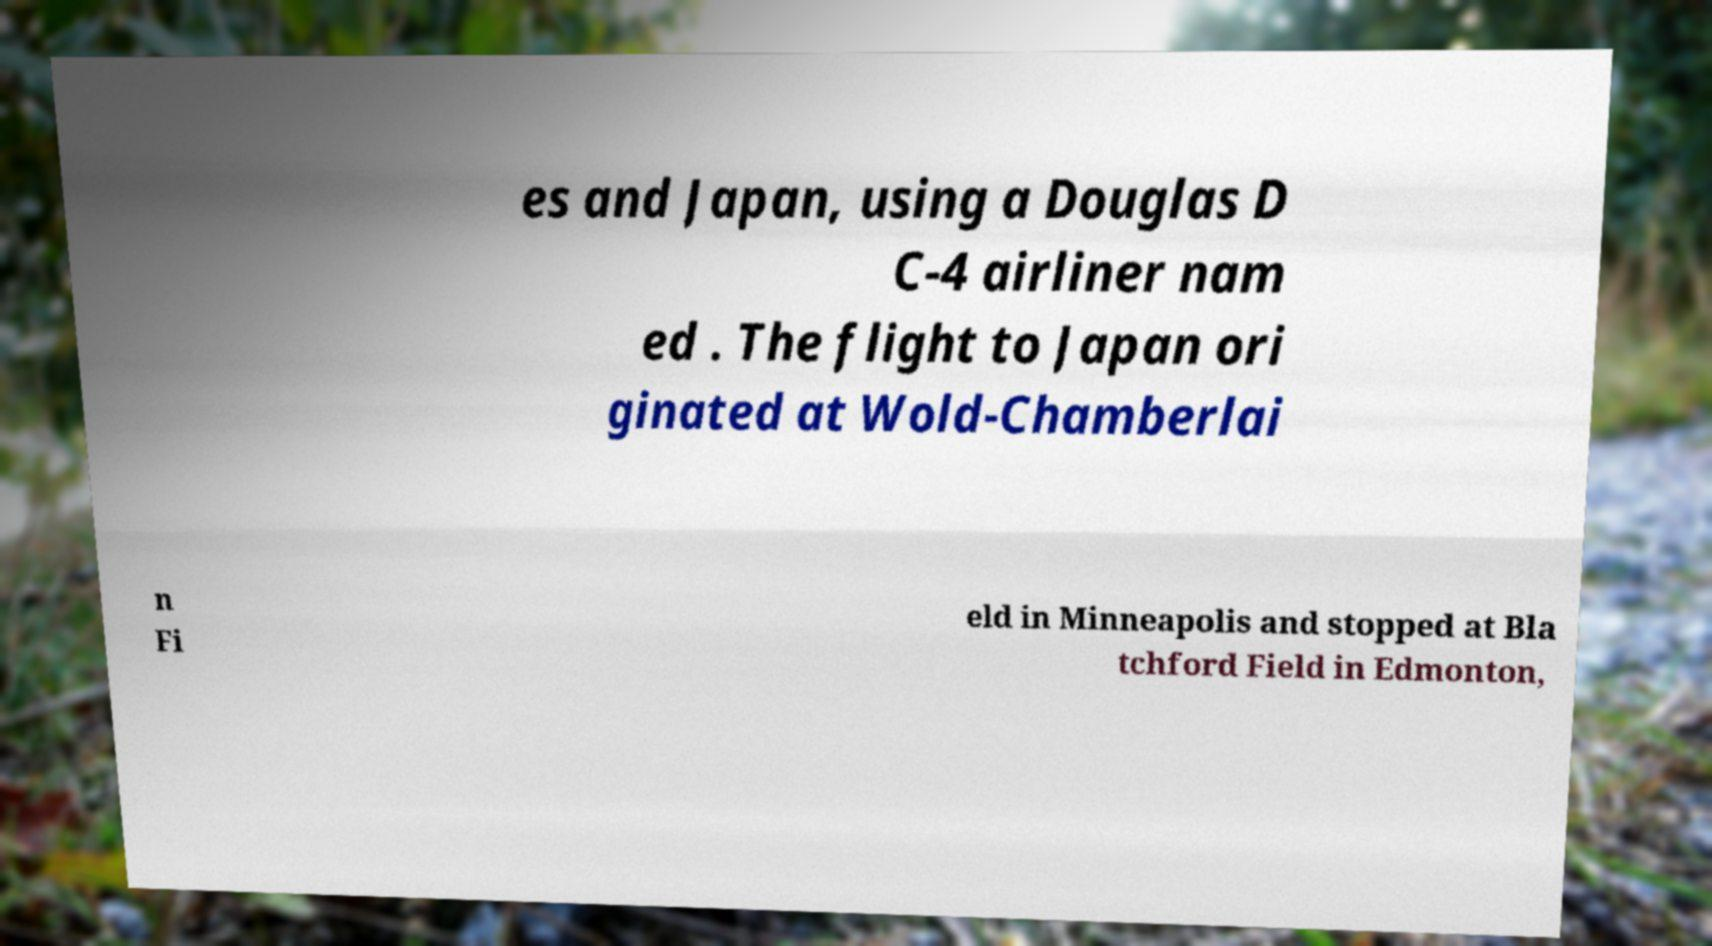Can you accurately transcribe the text from the provided image for me? es and Japan, using a Douglas D C-4 airliner nam ed . The flight to Japan ori ginated at Wold-Chamberlai n Fi eld in Minneapolis and stopped at Bla tchford Field in Edmonton, 